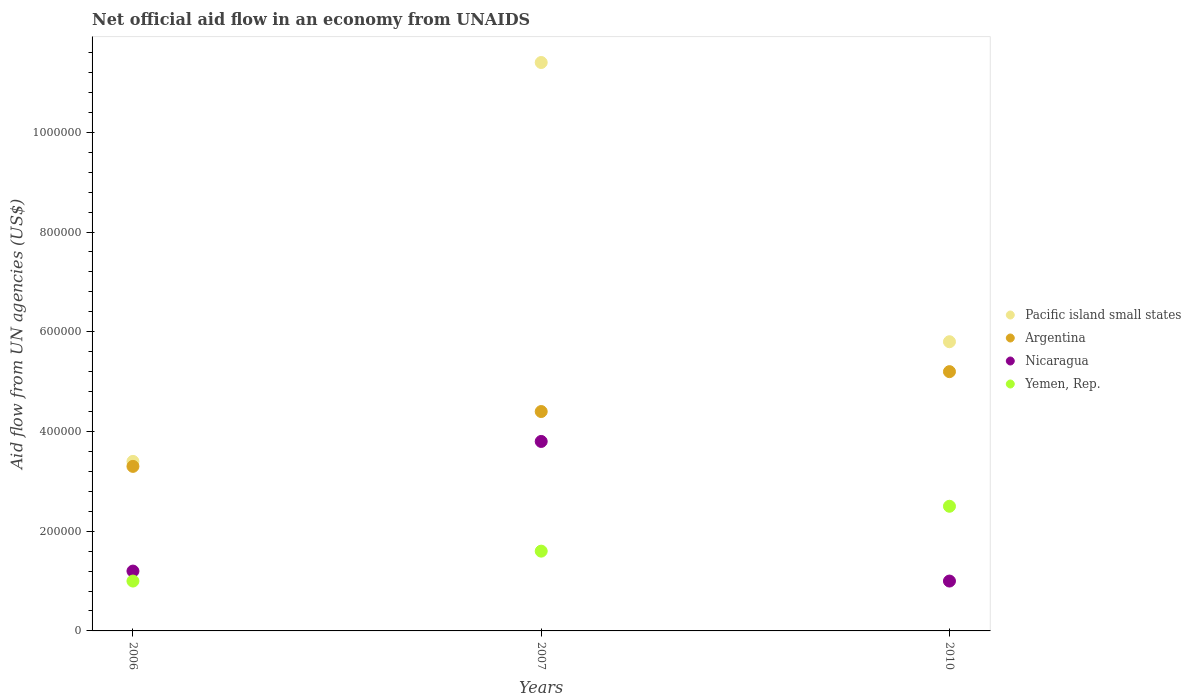How many different coloured dotlines are there?
Your answer should be very brief. 4. Is the number of dotlines equal to the number of legend labels?
Provide a succinct answer. Yes. What is the net official aid flow in Yemen, Rep. in 2010?
Keep it short and to the point. 2.50e+05. Across all years, what is the maximum net official aid flow in Argentina?
Keep it short and to the point. 5.20e+05. Across all years, what is the minimum net official aid flow in Nicaragua?
Ensure brevity in your answer.  1.00e+05. What is the total net official aid flow in Yemen, Rep. in the graph?
Offer a very short reply. 5.10e+05. What is the difference between the net official aid flow in Nicaragua in 2006 and that in 2007?
Give a very brief answer. -2.60e+05. What is the difference between the net official aid flow in Pacific island small states in 2007 and the net official aid flow in Nicaragua in 2010?
Give a very brief answer. 1.04e+06. What is the average net official aid flow in Yemen, Rep. per year?
Provide a short and direct response. 1.70e+05. In the year 2006, what is the difference between the net official aid flow in Yemen, Rep. and net official aid flow in Nicaragua?
Offer a very short reply. -2.00e+04. What is the ratio of the net official aid flow in Yemen, Rep. in 2006 to that in 2010?
Offer a terse response. 0.4. What is the difference between the highest and the second highest net official aid flow in Argentina?
Offer a very short reply. 8.00e+04. What is the difference between the highest and the lowest net official aid flow in Yemen, Rep.?
Your response must be concise. 1.50e+05. In how many years, is the net official aid flow in Yemen, Rep. greater than the average net official aid flow in Yemen, Rep. taken over all years?
Your response must be concise. 1. Is the sum of the net official aid flow in Pacific island small states in 2006 and 2007 greater than the maximum net official aid flow in Argentina across all years?
Provide a short and direct response. Yes. Is it the case that in every year, the sum of the net official aid flow in Pacific island small states and net official aid flow in Yemen, Rep.  is greater than the net official aid flow in Nicaragua?
Make the answer very short. Yes. Is the net official aid flow in Argentina strictly greater than the net official aid flow in Pacific island small states over the years?
Make the answer very short. No. Does the graph contain any zero values?
Keep it short and to the point. No. Does the graph contain grids?
Your answer should be very brief. No. How many legend labels are there?
Your answer should be very brief. 4. What is the title of the graph?
Your answer should be compact. Net official aid flow in an economy from UNAIDS. Does "Timor-Leste" appear as one of the legend labels in the graph?
Keep it short and to the point. No. What is the label or title of the Y-axis?
Provide a short and direct response. Aid flow from UN agencies (US$). What is the Aid flow from UN agencies (US$) of Pacific island small states in 2006?
Offer a very short reply. 3.40e+05. What is the Aid flow from UN agencies (US$) of Pacific island small states in 2007?
Ensure brevity in your answer.  1.14e+06. What is the Aid flow from UN agencies (US$) in Argentina in 2007?
Make the answer very short. 4.40e+05. What is the Aid flow from UN agencies (US$) in Yemen, Rep. in 2007?
Your answer should be very brief. 1.60e+05. What is the Aid flow from UN agencies (US$) of Pacific island small states in 2010?
Offer a very short reply. 5.80e+05. What is the Aid flow from UN agencies (US$) in Argentina in 2010?
Provide a short and direct response. 5.20e+05. What is the Aid flow from UN agencies (US$) in Nicaragua in 2010?
Provide a succinct answer. 1.00e+05. Across all years, what is the maximum Aid flow from UN agencies (US$) in Pacific island small states?
Your response must be concise. 1.14e+06. Across all years, what is the maximum Aid flow from UN agencies (US$) of Argentina?
Make the answer very short. 5.20e+05. Across all years, what is the maximum Aid flow from UN agencies (US$) of Nicaragua?
Give a very brief answer. 3.80e+05. Across all years, what is the minimum Aid flow from UN agencies (US$) of Argentina?
Offer a terse response. 3.30e+05. What is the total Aid flow from UN agencies (US$) of Pacific island small states in the graph?
Keep it short and to the point. 2.06e+06. What is the total Aid flow from UN agencies (US$) in Argentina in the graph?
Offer a terse response. 1.29e+06. What is the total Aid flow from UN agencies (US$) of Nicaragua in the graph?
Provide a short and direct response. 6.00e+05. What is the total Aid flow from UN agencies (US$) of Yemen, Rep. in the graph?
Provide a succinct answer. 5.10e+05. What is the difference between the Aid flow from UN agencies (US$) in Pacific island small states in 2006 and that in 2007?
Provide a succinct answer. -8.00e+05. What is the difference between the Aid flow from UN agencies (US$) of Argentina in 2006 and that in 2007?
Keep it short and to the point. -1.10e+05. What is the difference between the Aid flow from UN agencies (US$) of Pacific island small states in 2006 and that in 2010?
Your answer should be very brief. -2.40e+05. What is the difference between the Aid flow from UN agencies (US$) in Argentina in 2006 and that in 2010?
Your response must be concise. -1.90e+05. What is the difference between the Aid flow from UN agencies (US$) of Yemen, Rep. in 2006 and that in 2010?
Provide a short and direct response. -1.50e+05. What is the difference between the Aid flow from UN agencies (US$) in Pacific island small states in 2007 and that in 2010?
Give a very brief answer. 5.60e+05. What is the difference between the Aid flow from UN agencies (US$) of Nicaragua in 2007 and that in 2010?
Offer a terse response. 2.80e+05. What is the difference between the Aid flow from UN agencies (US$) in Yemen, Rep. in 2007 and that in 2010?
Provide a succinct answer. -9.00e+04. What is the difference between the Aid flow from UN agencies (US$) of Pacific island small states in 2006 and the Aid flow from UN agencies (US$) of Nicaragua in 2007?
Your response must be concise. -4.00e+04. What is the difference between the Aid flow from UN agencies (US$) of Pacific island small states in 2006 and the Aid flow from UN agencies (US$) of Yemen, Rep. in 2007?
Offer a terse response. 1.80e+05. What is the difference between the Aid flow from UN agencies (US$) of Pacific island small states in 2006 and the Aid flow from UN agencies (US$) of Argentina in 2010?
Give a very brief answer. -1.80e+05. What is the difference between the Aid flow from UN agencies (US$) of Pacific island small states in 2006 and the Aid flow from UN agencies (US$) of Nicaragua in 2010?
Provide a succinct answer. 2.40e+05. What is the difference between the Aid flow from UN agencies (US$) in Pacific island small states in 2006 and the Aid flow from UN agencies (US$) in Yemen, Rep. in 2010?
Your response must be concise. 9.00e+04. What is the difference between the Aid flow from UN agencies (US$) of Argentina in 2006 and the Aid flow from UN agencies (US$) of Nicaragua in 2010?
Offer a very short reply. 2.30e+05. What is the difference between the Aid flow from UN agencies (US$) in Pacific island small states in 2007 and the Aid flow from UN agencies (US$) in Argentina in 2010?
Ensure brevity in your answer.  6.20e+05. What is the difference between the Aid flow from UN agencies (US$) of Pacific island small states in 2007 and the Aid flow from UN agencies (US$) of Nicaragua in 2010?
Make the answer very short. 1.04e+06. What is the difference between the Aid flow from UN agencies (US$) in Pacific island small states in 2007 and the Aid flow from UN agencies (US$) in Yemen, Rep. in 2010?
Your response must be concise. 8.90e+05. What is the average Aid flow from UN agencies (US$) of Pacific island small states per year?
Make the answer very short. 6.87e+05. What is the average Aid flow from UN agencies (US$) in Yemen, Rep. per year?
Offer a terse response. 1.70e+05. In the year 2006, what is the difference between the Aid flow from UN agencies (US$) of Pacific island small states and Aid flow from UN agencies (US$) of Nicaragua?
Offer a very short reply. 2.20e+05. In the year 2006, what is the difference between the Aid flow from UN agencies (US$) of Pacific island small states and Aid flow from UN agencies (US$) of Yemen, Rep.?
Give a very brief answer. 2.40e+05. In the year 2007, what is the difference between the Aid flow from UN agencies (US$) in Pacific island small states and Aid flow from UN agencies (US$) in Nicaragua?
Provide a succinct answer. 7.60e+05. In the year 2007, what is the difference between the Aid flow from UN agencies (US$) of Pacific island small states and Aid flow from UN agencies (US$) of Yemen, Rep.?
Provide a succinct answer. 9.80e+05. In the year 2007, what is the difference between the Aid flow from UN agencies (US$) in Argentina and Aid flow from UN agencies (US$) in Nicaragua?
Keep it short and to the point. 6.00e+04. In the year 2007, what is the difference between the Aid flow from UN agencies (US$) of Nicaragua and Aid flow from UN agencies (US$) of Yemen, Rep.?
Your response must be concise. 2.20e+05. In the year 2010, what is the difference between the Aid flow from UN agencies (US$) of Pacific island small states and Aid flow from UN agencies (US$) of Nicaragua?
Ensure brevity in your answer.  4.80e+05. In the year 2010, what is the difference between the Aid flow from UN agencies (US$) in Pacific island small states and Aid flow from UN agencies (US$) in Yemen, Rep.?
Offer a terse response. 3.30e+05. In the year 2010, what is the difference between the Aid flow from UN agencies (US$) in Argentina and Aid flow from UN agencies (US$) in Yemen, Rep.?
Make the answer very short. 2.70e+05. In the year 2010, what is the difference between the Aid flow from UN agencies (US$) of Nicaragua and Aid flow from UN agencies (US$) of Yemen, Rep.?
Ensure brevity in your answer.  -1.50e+05. What is the ratio of the Aid flow from UN agencies (US$) of Pacific island small states in 2006 to that in 2007?
Provide a short and direct response. 0.3. What is the ratio of the Aid flow from UN agencies (US$) of Nicaragua in 2006 to that in 2007?
Offer a very short reply. 0.32. What is the ratio of the Aid flow from UN agencies (US$) of Pacific island small states in 2006 to that in 2010?
Offer a terse response. 0.59. What is the ratio of the Aid flow from UN agencies (US$) in Argentina in 2006 to that in 2010?
Your answer should be compact. 0.63. What is the ratio of the Aid flow from UN agencies (US$) in Nicaragua in 2006 to that in 2010?
Your answer should be very brief. 1.2. What is the ratio of the Aid flow from UN agencies (US$) in Pacific island small states in 2007 to that in 2010?
Ensure brevity in your answer.  1.97. What is the ratio of the Aid flow from UN agencies (US$) in Argentina in 2007 to that in 2010?
Your answer should be very brief. 0.85. What is the ratio of the Aid flow from UN agencies (US$) of Nicaragua in 2007 to that in 2010?
Provide a short and direct response. 3.8. What is the ratio of the Aid flow from UN agencies (US$) of Yemen, Rep. in 2007 to that in 2010?
Offer a very short reply. 0.64. What is the difference between the highest and the second highest Aid flow from UN agencies (US$) of Pacific island small states?
Give a very brief answer. 5.60e+05. What is the difference between the highest and the second highest Aid flow from UN agencies (US$) of Nicaragua?
Your answer should be very brief. 2.60e+05. What is the difference between the highest and the lowest Aid flow from UN agencies (US$) of Yemen, Rep.?
Give a very brief answer. 1.50e+05. 